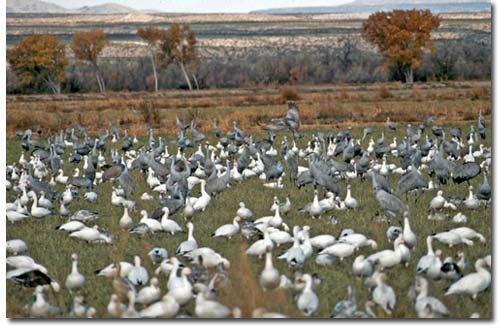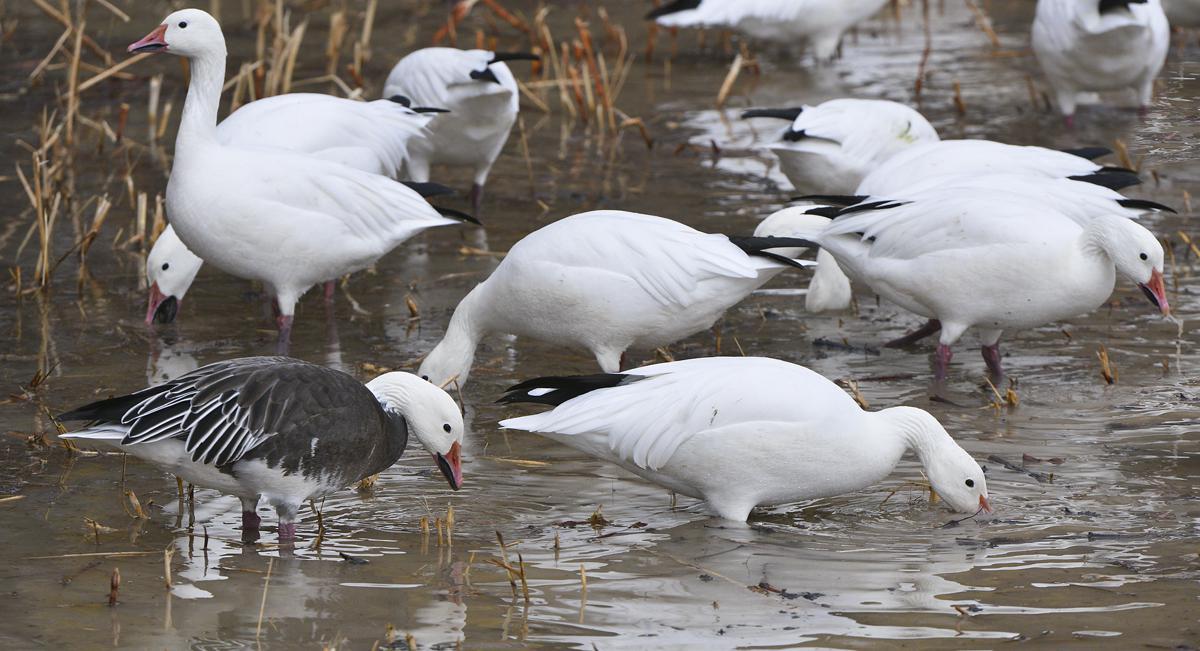The first image is the image on the left, the second image is the image on the right. For the images displayed, is the sentence "At least one of the images has geese in brown grass." factually correct? Answer yes or no. No. 